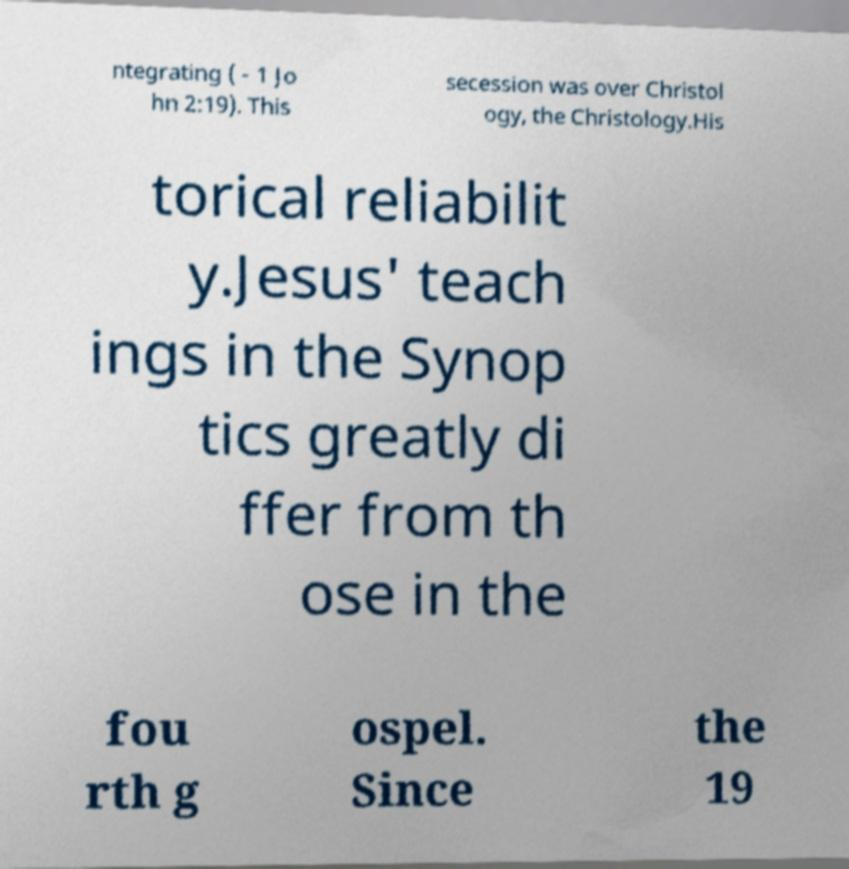Could you extract and type out the text from this image? ntegrating ( - 1 Jo hn 2:19). This secession was over Christol ogy, the Christology.His torical reliabilit y.Jesus' teach ings in the Synop tics greatly di ffer from th ose in the fou rth g ospel. Since the 19 